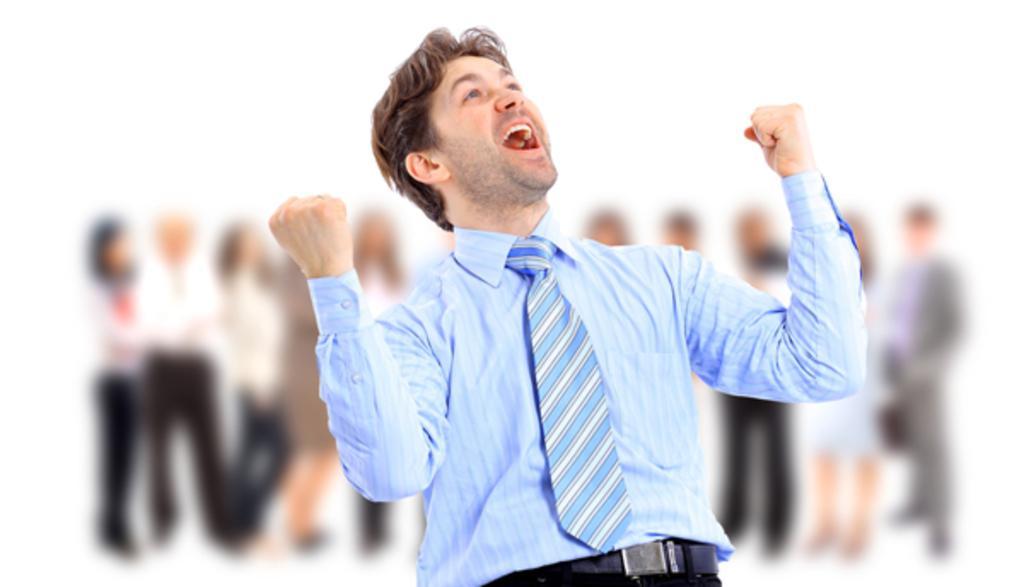Describe this image in one or two sentences. In this image I can see a person wearing blue shirt, blue and white colored tie and black color pant is standing. I can see the blurry background in which I can see few persons standing. 